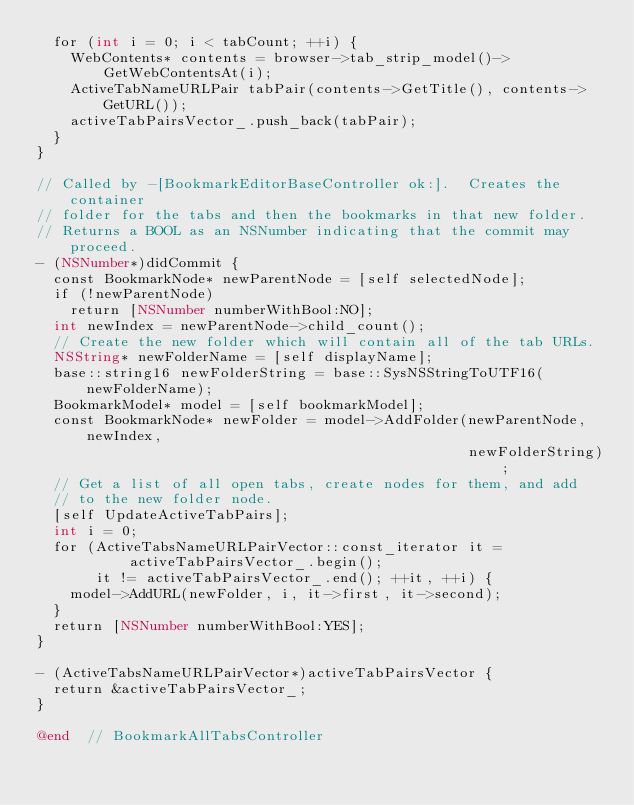<code> <loc_0><loc_0><loc_500><loc_500><_ObjectiveC_>  for (int i = 0; i < tabCount; ++i) {
    WebContents* contents = browser->tab_strip_model()->GetWebContentsAt(i);
    ActiveTabNameURLPair tabPair(contents->GetTitle(), contents->GetURL());
    activeTabPairsVector_.push_back(tabPair);
  }
}

// Called by -[BookmarkEditorBaseController ok:].  Creates the container
// folder for the tabs and then the bookmarks in that new folder.
// Returns a BOOL as an NSNumber indicating that the commit may proceed.
- (NSNumber*)didCommit {
  const BookmarkNode* newParentNode = [self selectedNode];
  if (!newParentNode)
    return [NSNumber numberWithBool:NO];
  int newIndex = newParentNode->child_count();
  // Create the new folder which will contain all of the tab URLs.
  NSString* newFolderName = [self displayName];
  base::string16 newFolderString = base::SysNSStringToUTF16(newFolderName);
  BookmarkModel* model = [self bookmarkModel];
  const BookmarkNode* newFolder = model->AddFolder(newParentNode, newIndex,
                                                   newFolderString);
  // Get a list of all open tabs, create nodes for them, and add
  // to the new folder node.
  [self UpdateActiveTabPairs];
  int i = 0;
  for (ActiveTabsNameURLPairVector::const_iterator it =
           activeTabPairsVector_.begin();
       it != activeTabPairsVector_.end(); ++it, ++i) {
    model->AddURL(newFolder, i, it->first, it->second);
  }
  return [NSNumber numberWithBool:YES];
}

- (ActiveTabsNameURLPairVector*)activeTabPairsVector {
  return &activeTabPairsVector_;
}

@end  // BookmarkAllTabsController

</code> 